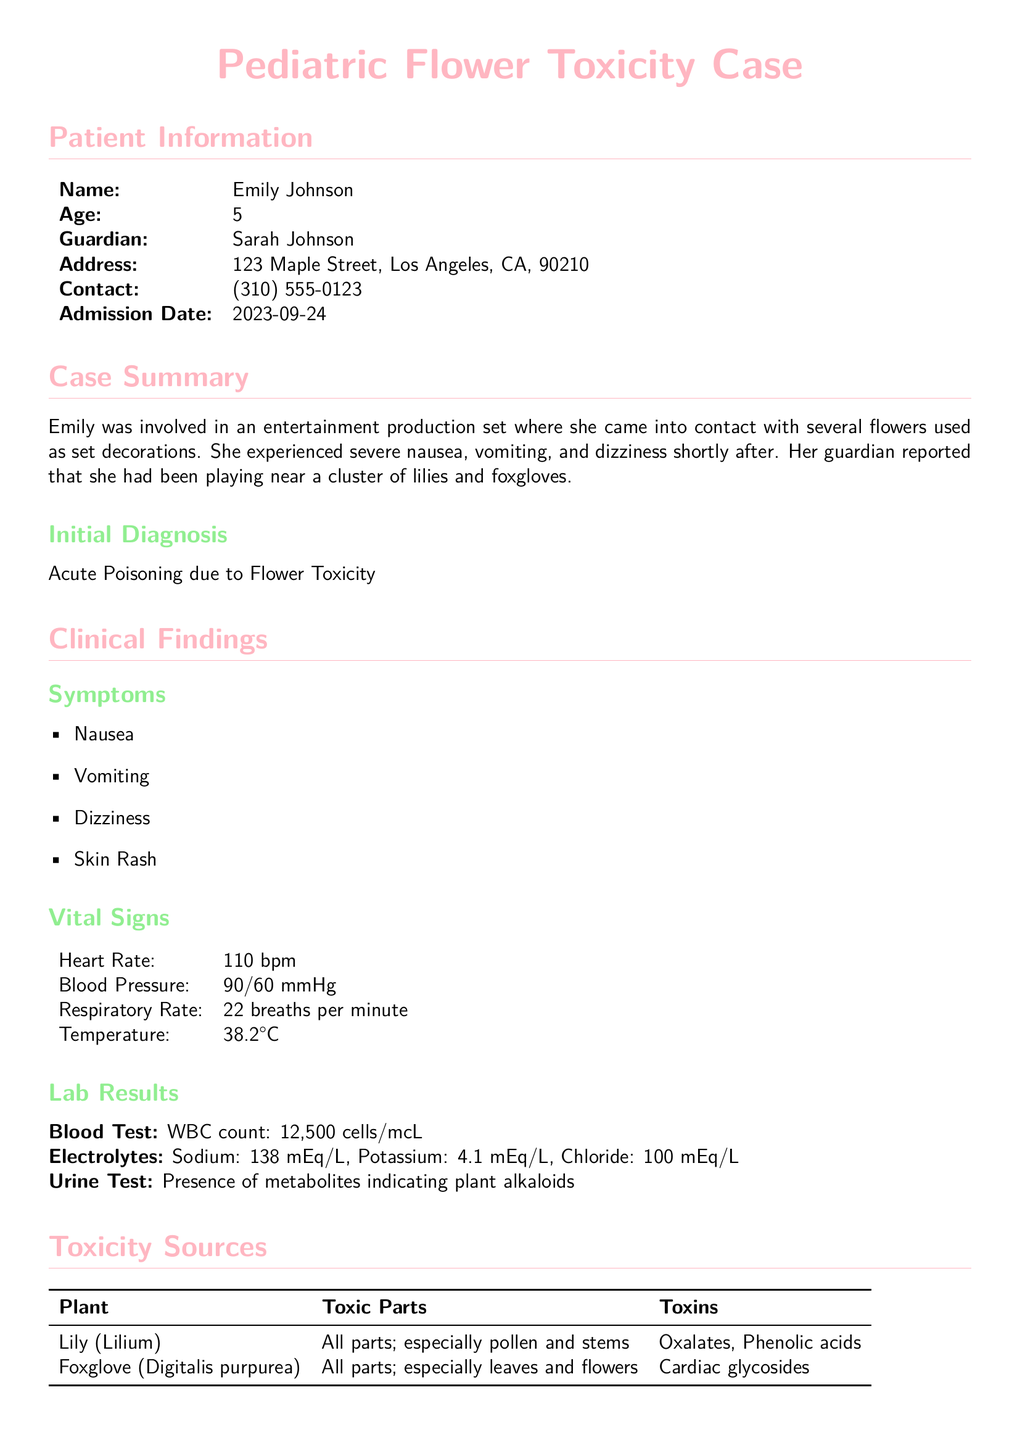What is the patient's name? The patient's name is listed in the document under patient information.
Answer: Emily Johnson What is the age of the patient? The age of the patient is specified directly in the patient information section of the document.
Answer: 5 What were the initial symptoms experienced by Emily? The symptoms are listed clearly in the clinical findings section, indicating her health issues.
Answer: Nausea What toxins are found in lilies? The toxins present in lilies are detailed in the toxicity sources table, which specifies harmful substances.
Answer: Oxalates, Phenolic acids What was the treatment provided for hydration? The treatment for hydration is mentioned under the treatment administered section, indicating supportive care measures taken.
Answer: Intravenous fluids How many days until the follow-up appointment is scheduled? The follow-up appointment duration is directly stated in the discharge plan section of the document.
Answer: 7 days What part of the foxglove plant contains toxins? The toxic parts of the foxglove plant are listed in the toxicity sources section, detailing where the harm originates.
Answer: All parts; especially leaves and flowers What is the patient's guardian's name? The document specifies the guardian's name in the patient information section.
Answer: Sarah Johnson What is the heart rate recorded for Emily? Heart rate details can be found in the vital signs section, providing important clinical data.
Answer: 110 bpm 